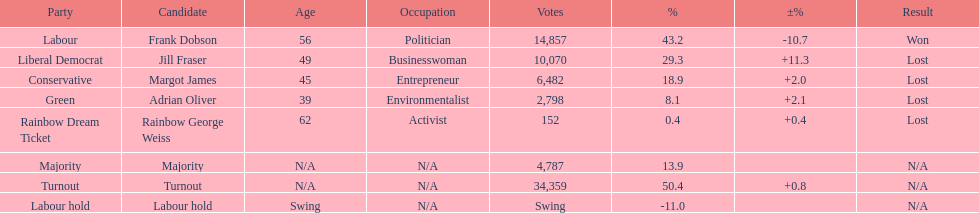Write the full table. {'header': ['Party', 'Candidate', 'Age', 'Occupation', 'Votes', '%', '±%', 'Result'], 'rows': [['Labour', 'Frank Dobson', '56', 'Politician', '14,857', '43.2', '-10.7', 'Won'], ['Liberal Democrat', 'Jill Fraser', '49', 'Businesswoman', '10,070', '29.3', '+11.3', 'Lost'], ['Conservative', 'Margot James', '45', 'Entrepreneur', '6,482', '18.9', '+2.0', 'Lost'], ['Green', 'Adrian Oliver', '39', 'Environmentalist', '2,798', '8.1', '+2.1', 'Lost'], ['Rainbow Dream Ticket', 'Rainbow George Weiss', '62', 'Activist', '152', '0.4', '+0.4', 'Lost'], ['Majority', 'Majority', 'N/A', 'N/A', '4,787', '13.9', '', 'N/A'], ['Turnout', 'Turnout', 'N/A', 'N/A', '34,359', '50.4', '+0.8', 'N/A'], ['Labour hold', 'Labour hold', 'Swing', 'N/A', 'Swing', '-11.0', '', 'N/A']]} How many votes did both the conservative party and the rainbow dream ticket party receive? 6634. 